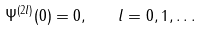<formula> <loc_0><loc_0><loc_500><loc_500>\Psi ^ { ( 2 l ) } ( 0 ) = 0 , \quad l = 0 , 1 , \dots</formula> 